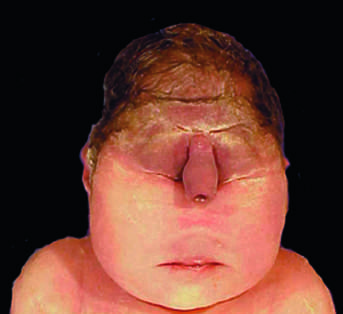what is stillbirth associated with, in which the midface structures are fused or ill-formed?
Answer the question using a single word or phrase. A lethal malformation 